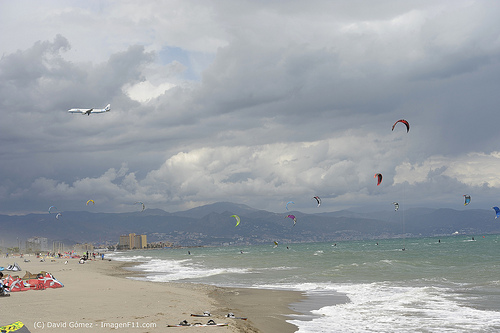What safety measures should be taken for kite surfers on this beach? Kite surfers should ensure they are wearing appropriate safety gear, including a helmet, a life vest, and a harness. They should always check their equipment for any damage before use and be aware of weather conditions to avoid strong or unpredictable winds. Additionally, maintaining a safe distance from other beach activities and people is essential to prevent collisions and potential injuries. It is also crucial to follow instructions and guidelines provided by experienced instructors or lifeguards present on the beach. 